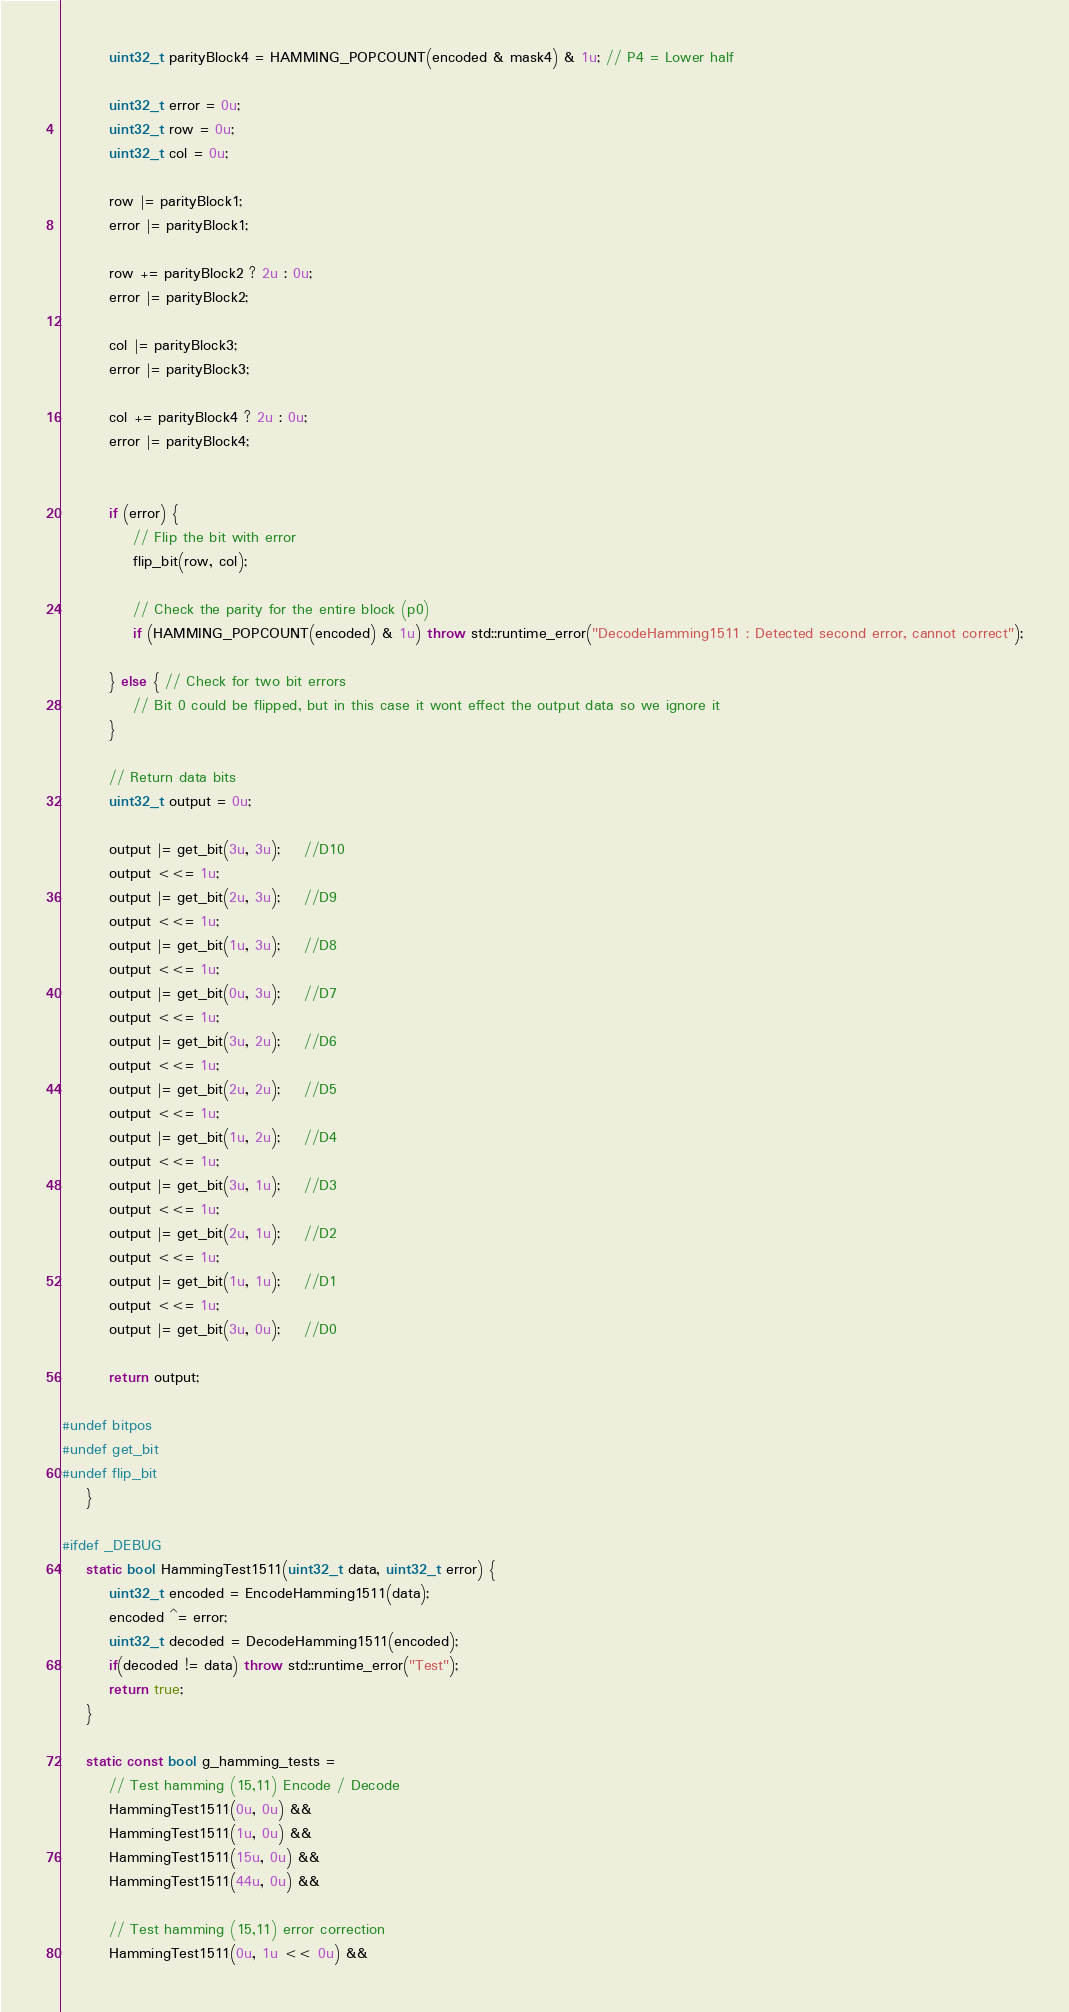Convert code to text. <code><loc_0><loc_0><loc_500><loc_500><_C++_>		uint32_t parityBlock4 = HAMMING_POPCOUNT(encoded & mask4) & 1u; // P4 = Lower half

		uint32_t error = 0u;
		uint32_t row = 0u;
		uint32_t col = 0u;

		row |= parityBlock1;
		error |= parityBlock1;

		row += parityBlock2 ? 2u : 0u;
		error |= parityBlock2;

		col |= parityBlock3;
		error |= parityBlock3;

		col += parityBlock4 ? 2u : 0u;
		error |= parityBlock4;


		if (error) {
			// Flip the bit with error
			flip_bit(row, col);

			// Check the parity for the entire block (p0)
			if (HAMMING_POPCOUNT(encoded) & 1u) throw std::runtime_error("DecodeHamming1511 : Detected second error, cannot correct");

		} else { // Check for two bit errors
			// Bit 0 could be flipped, but in this case it wont effect the output data so we ignore it
		}

		// Return data bits
		uint32_t output = 0u;

		output |= get_bit(3u, 3u);	//D10
		output <<= 1u;
		output |= get_bit(2u, 3u);	//D9
		output <<= 1u;
		output |= get_bit(1u, 3u);	//D8
		output <<= 1u;
		output |= get_bit(0u, 3u);	//D7
		output <<= 1u;
		output |= get_bit(3u, 2u);	//D6
		output <<= 1u;
		output |= get_bit(2u, 2u);	//D5
		output <<= 1u;
		output |= get_bit(1u, 2u);	//D4
		output <<= 1u;
		output |= get_bit(3u, 1u);	//D3
		output <<= 1u;
		output |= get_bit(2u, 1u);	//D2
		output <<= 1u;
		output |= get_bit(1u, 1u);	//D1
		output <<= 1u;
		output |= get_bit(3u, 0u);	//D0

		return output;

#undef bitpos
#undef get_bit
#undef flip_bit
	}

#ifdef _DEBUG
	static bool HammingTest1511(uint32_t data, uint32_t error) {
		uint32_t encoded = EncodeHamming1511(data);
		encoded ^= error;
		uint32_t decoded = DecodeHamming1511(encoded);
		if(decoded != data) throw std::runtime_error("Test");
		return true;
	}

	static const bool g_hamming_tests =
		// Test hamming (15,11) Encode / Decode
		HammingTest1511(0u, 0u) &&
		HammingTest1511(1u, 0u) &&
		HammingTest1511(15u, 0u) &&
		HammingTest1511(44u, 0u) &&

		// Test hamming (15,11) error correction
		HammingTest1511(0u, 1u << 0u) &&</code> 